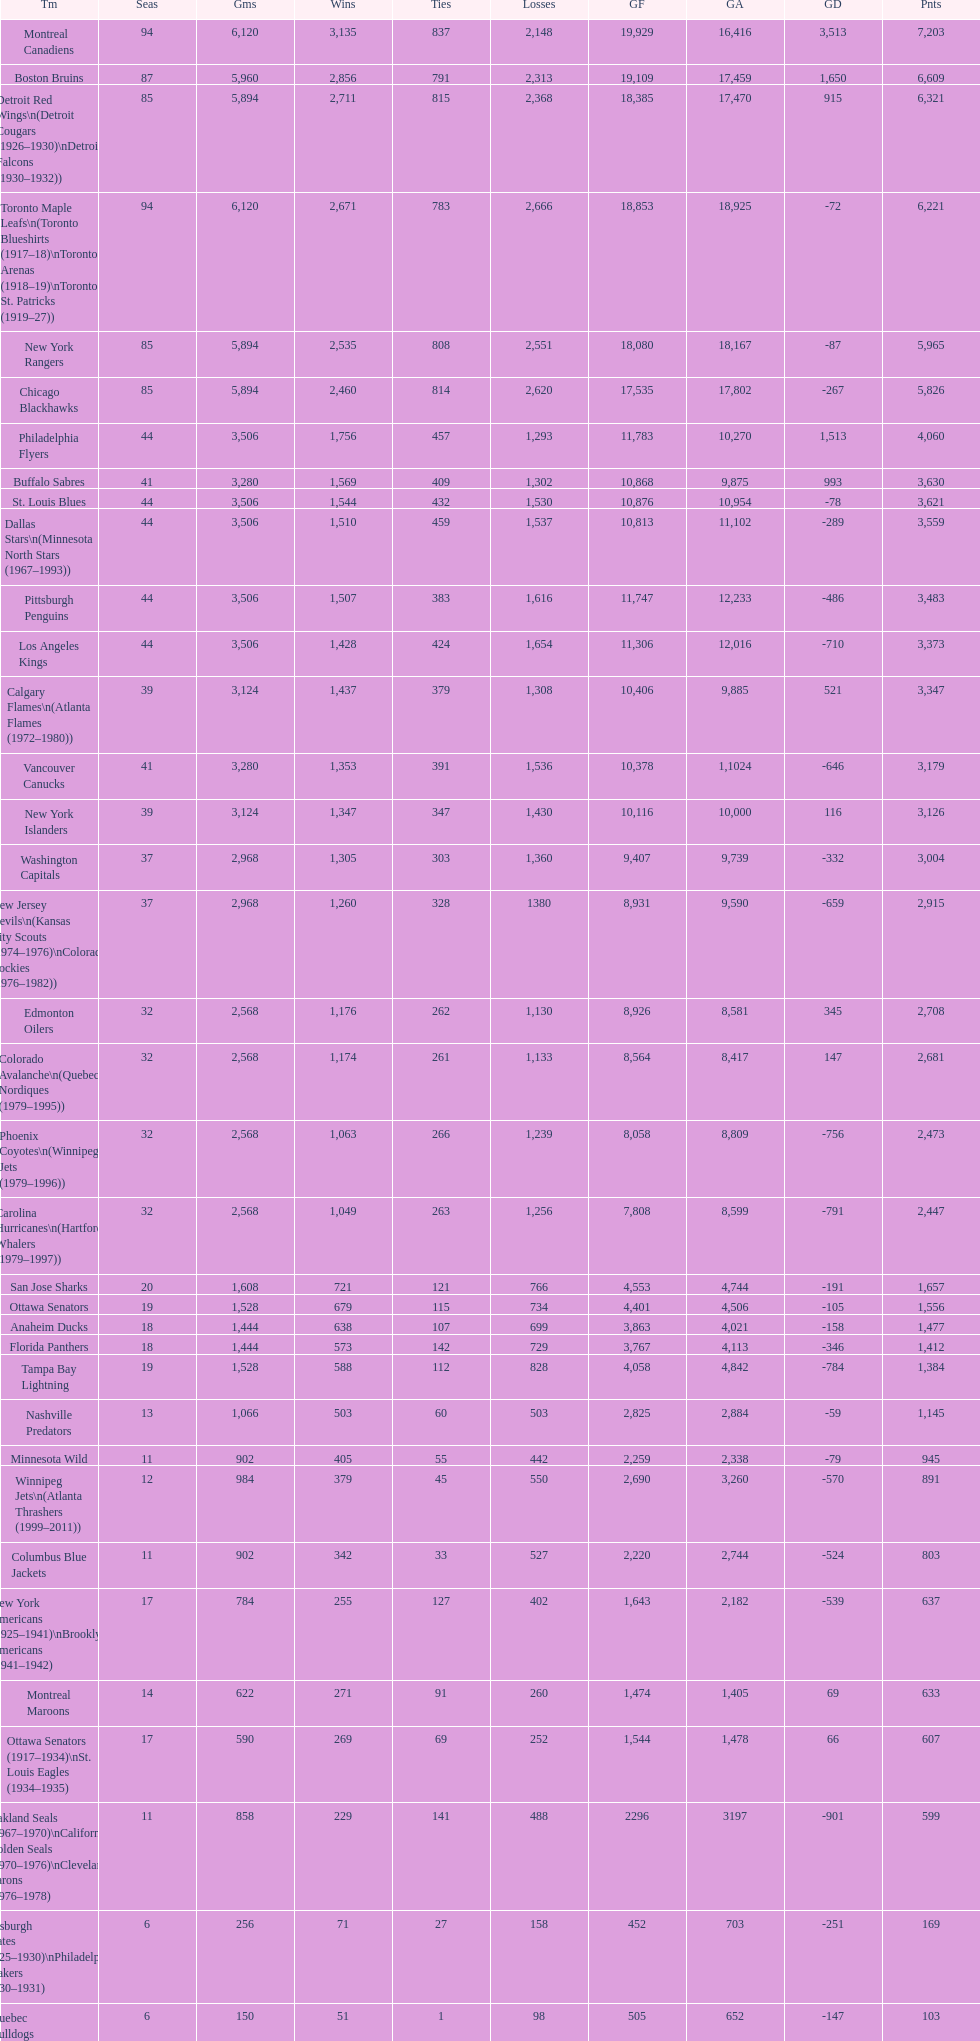How many losses do the st. louis blues have? 1,530. 